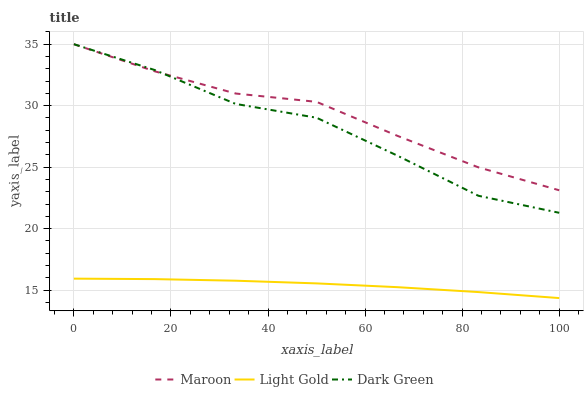Does Light Gold have the minimum area under the curve?
Answer yes or no. Yes. Does Maroon have the maximum area under the curve?
Answer yes or no. Yes. Does Dark Green have the minimum area under the curve?
Answer yes or no. No. Does Dark Green have the maximum area under the curve?
Answer yes or no. No. Is Light Gold the smoothest?
Answer yes or no. Yes. Is Dark Green the roughest?
Answer yes or no. Yes. Is Maroon the smoothest?
Answer yes or no. No. Is Maroon the roughest?
Answer yes or no. No. Does Light Gold have the lowest value?
Answer yes or no. Yes. Does Dark Green have the lowest value?
Answer yes or no. No. Does Dark Green have the highest value?
Answer yes or no. Yes. Is Light Gold less than Maroon?
Answer yes or no. Yes. Is Dark Green greater than Light Gold?
Answer yes or no. Yes. Does Maroon intersect Dark Green?
Answer yes or no. Yes. Is Maroon less than Dark Green?
Answer yes or no. No. Is Maroon greater than Dark Green?
Answer yes or no. No. Does Light Gold intersect Maroon?
Answer yes or no. No. 